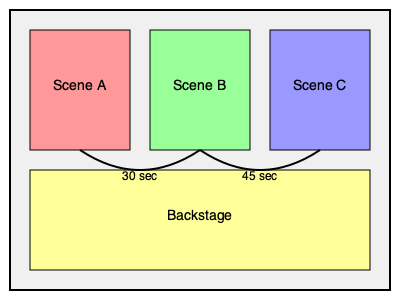A former child star is performing in a play with quick scene transitions. The diagram shows the layout of the stage and backstage area, with the time required for costume changes between scenes. If the actor needs to change costumes completely between each scene and can move at a speed of 2 meters per second, what is the minimum width of the backstage area required to ensure successful costume changes? To solve this problem, we need to follow these steps:

1. Identify the quickest transition: 30 seconds between Scene A and Scene B.

2. Calculate the distance the actor can cover in 30 seconds:
   Distance = Speed × Time
   Distance = 2 m/s × 30 s = 60 meters

3. Consider the round trip:
   The actor needs to go from Scene A to backstage, change costume, and return to Scene B.
   So, the total distance available is 60 meters ÷ 2 = 30 meters

4. Account for costume change time:
   Let's assume the costume change takes about 20 seconds.
   Time for movement = 30 seconds - 20 seconds = 10 seconds

5. Calculate the distance for one-way trip:
   One-way distance = 2 m/s × 10 s ÷ 2 = 10 meters

6. The minimum width of the backstage area:
   To ensure the actor can reach the costume change area and return in time, the backstage width should be at least 10 meters.

Therefore, the minimum width of the backstage area should be 10 meters to accommodate the quickest transition while allowing time for a complete costume change.
Answer: 10 meters 